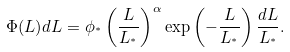<formula> <loc_0><loc_0><loc_500><loc_500>\Phi ( L ) d L = \phi _ { ^ { * } } \left ( \frac { L } { L _ { ^ { * } } } \right ) ^ { \alpha } \exp \left ( - \frac { L } { L _ { ^ { * } } } \right ) \frac { d L } { L _ { ^ { * } } } .</formula> 